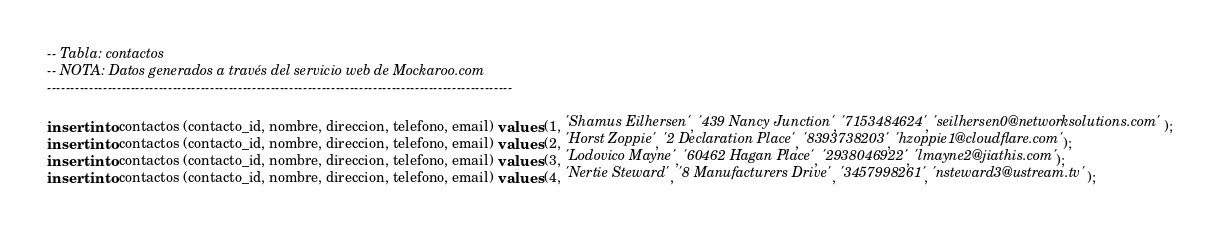Convert code to text. <code><loc_0><loc_0><loc_500><loc_500><_SQL_>-- Tabla: contactos
-- NOTA: Datos generados a través del servicio web de Mockaroo.com
----------------------------------------------------------------------------------------------------

insert into contactos (contacto_id, nombre, direccion, telefono, email) values (1, 'Shamus Eilhersen', '439 Nancy Junction', '7153484624', 'seilhersen0@networksolutions.com');
insert into contactos (contacto_id, nombre, direccion, telefono, email) values (2, 'Horst Zoppie', '2 Declaration Place', '8393738203', 'hzoppie1@cloudflare.com');
insert into contactos (contacto_id, nombre, direccion, telefono, email) values (3, 'Lodovico Mayne', '60462 Hagan Place', '2938046922', 'lmayne2@jiathis.com');
insert into contactos (contacto_id, nombre, direccion, telefono, email) values (4, 'Nertie Steward', '8 Manufacturers Drive', '3457998261', 'nsteward3@ustream.tv');</code> 